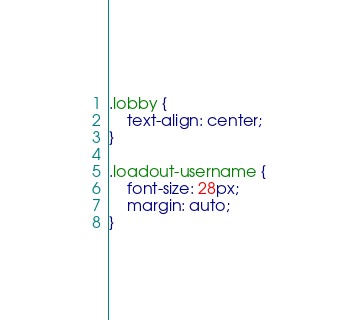Convert code to text. <code><loc_0><loc_0><loc_500><loc_500><_CSS_>.lobby {
    text-align: center;
}

.loadout-username {
    font-size: 28px;
    margin: auto;
}</code> 